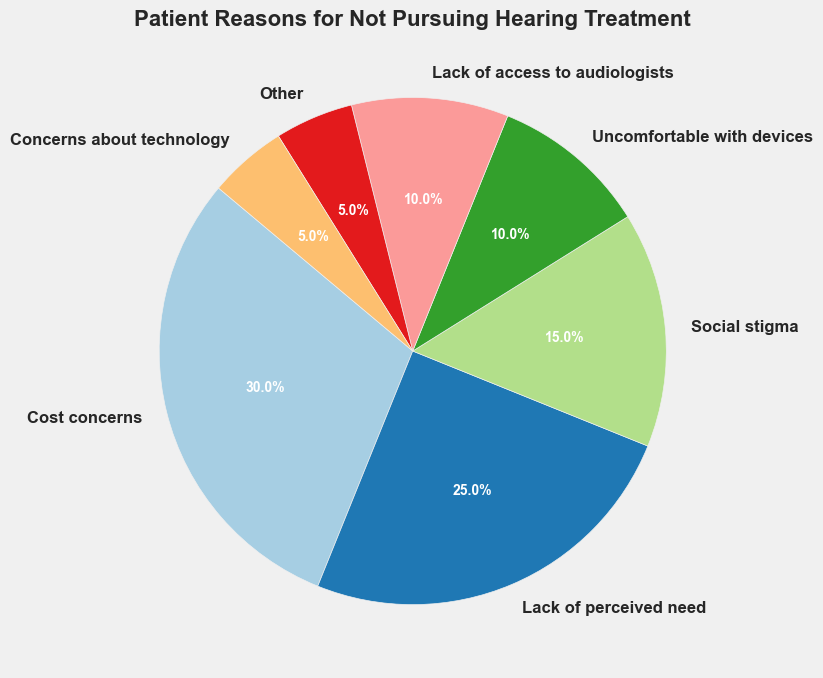what is the most common reason for not pursuing hearing treatment? The pie chart shows different reasons with their respective percentages. The largest slice represents the most common reason. "Cost concerns" has the largest slice with 30%
Answer: Cost concerns How does the percentage of patients citing "Lack of perceived need" compare to those citing "Social stigma"? The chart displays that "Lack of perceived need" has a 25% share, while "Social stigma" has a 15% share. Comparing these values, 25% is greater than 15%.
Answer: "Lack of perceived need" is greater Calculate the total percentage for reasons involving some kind of discomfort (physical or social). Adding the percentages associated with discomfort: "Social stigma" (15%) and "Uncomfortable with devices" (10%). The total is 15% + 10% = 25%
Answer: 25% What percentage of patients cite issues related to technology (either lack of access or technology concerns)? Adding the percentages for "Lack of access to audiologists" and "Concerns about technology": 10% + 5% = 15%
Answer: 15% How many reasons have an equal or higher percentage than "Social stigma"? The chart shows the following reasons with percentages higher or equal to 15%: "Cost concerns" (30%), "Lack of perceived need" (25%), and "Social stigma" itself (15%). Therefore, there are 3 reasons.
Answer: 3 What is the combined percentage of the least cited reasons "Other" and "Concerns about technology"? Adding the percentages for "Other" (5%) and "Concerns about technology" (5%): 5% + 5% = 10%
Answer: 10% Which reason has the smallest visual representation in the pie chart? The pie chart shows different slices with their percentages. "Other" and "Concerns about technology" have the smallest slices, both at 5%.
Answer: "Other" and "Concerns about technology" Which has more reasons cited by patients: those relating to healthcare providers or those relating to personal discomfort/preferences? For healthcare provider-related: "Lack of access to audiologists" (10%). For personal discomfort/preferences: "Lack of perceived need" (25%), "Social stigma" (15%), "Uncomfortable with devices" (10%). Adding these percentages: 25% + 15% + 10% = 50%. Comparing these groups, 50% is greater than 10%.
Answer: Personal discomfort/preferences What is the difference in percentage points between the highest and lowest cited reasons? The highest cited reason is "Cost concerns" (30%) and the lowest is "Other" and "Concerns about technology" (5%). The difference is 30% - 5% = 25%
Answer: 25% Which reason accounts for one-tenth of the cases mentioned? The chart shows different reasons with their percentages. "Uncomfortable with devices" and "Lack of access to audiologists" both account for 10%.
Answer: "Uncomfortable with devices" and "Lack of access to audiologists" 